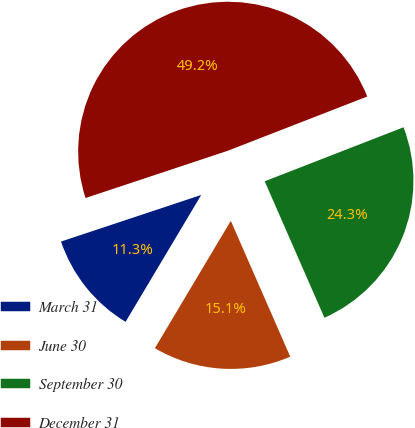Convert chart to OTSL. <chart><loc_0><loc_0><loc_500><loc_500><pie_chart><fcel>March 31<fcel>June 30<fcel>September 30<fcel>December 31<nl><fcel>11.34%<fcel>15.12%<fcel>24.34%<fcel>49.2%<nl></chart> 